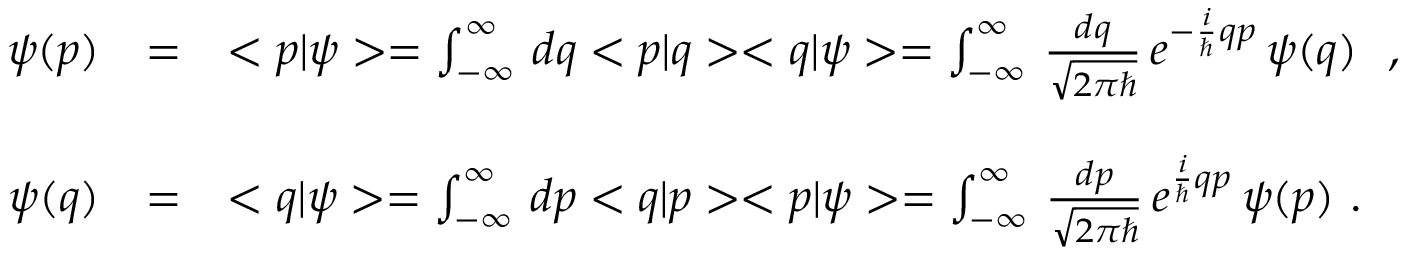<formula> <loc_0><loc_0><loc_500><loc_500>\begin{array} { r c l } { \psi ( p ) } & { = } & { { < p | \psi > = \int _ { - \infty } ^ { \infty } \, d q < p | q > < q | \psi > = \int _ { - \infty } ^ { \infty } \, \frac { d q } { \sqrt { 2 \pi } } \, e ^ { - \frac { i } { } q p } \, \psi ( q ) \ \ , \ \ } } \\ { \psi ( q ) } & { = } & { { < q | \psi > = \int _ { - \infty } ^ { \infty } \, d p < q | p > < p | \psi > = \int _ { - \infty } ^ { \infty } \, \frac { d p } { \sqrt { 2 \pi } } \, e ^ { \frac { i } { } q p } \, \psi ( p ) \ . } } \end{array}</formula> 